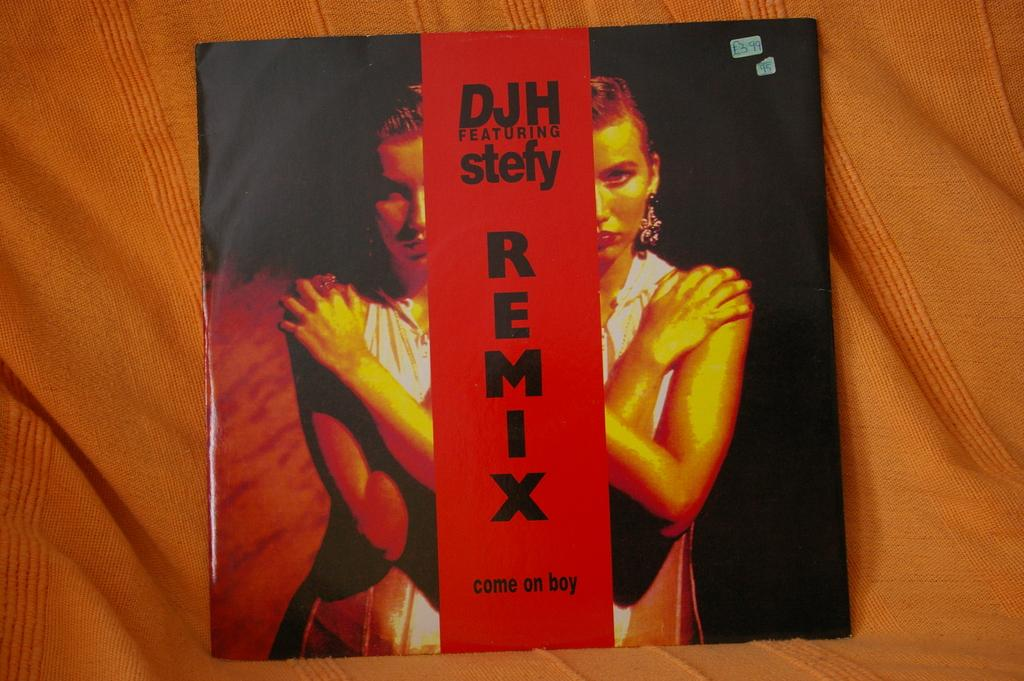<image>
Summarize the visual content of the image. A vinyl record by DJH featuring stefy titled come on boy remix. 